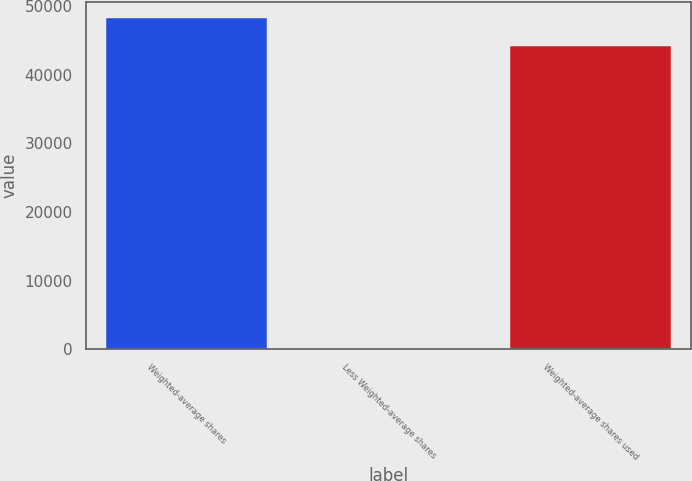Convert chart to OTSL. <chart><loc_0><loc_0><loc_500><loc_500><bar_chart><fcel>Weighted-average shares<fcel>Less Weighted-average shares<fcel>Weighted-average shares used<nl><fcel>48176.4<fcel>52<fcel>44161.7<nl></chart> 